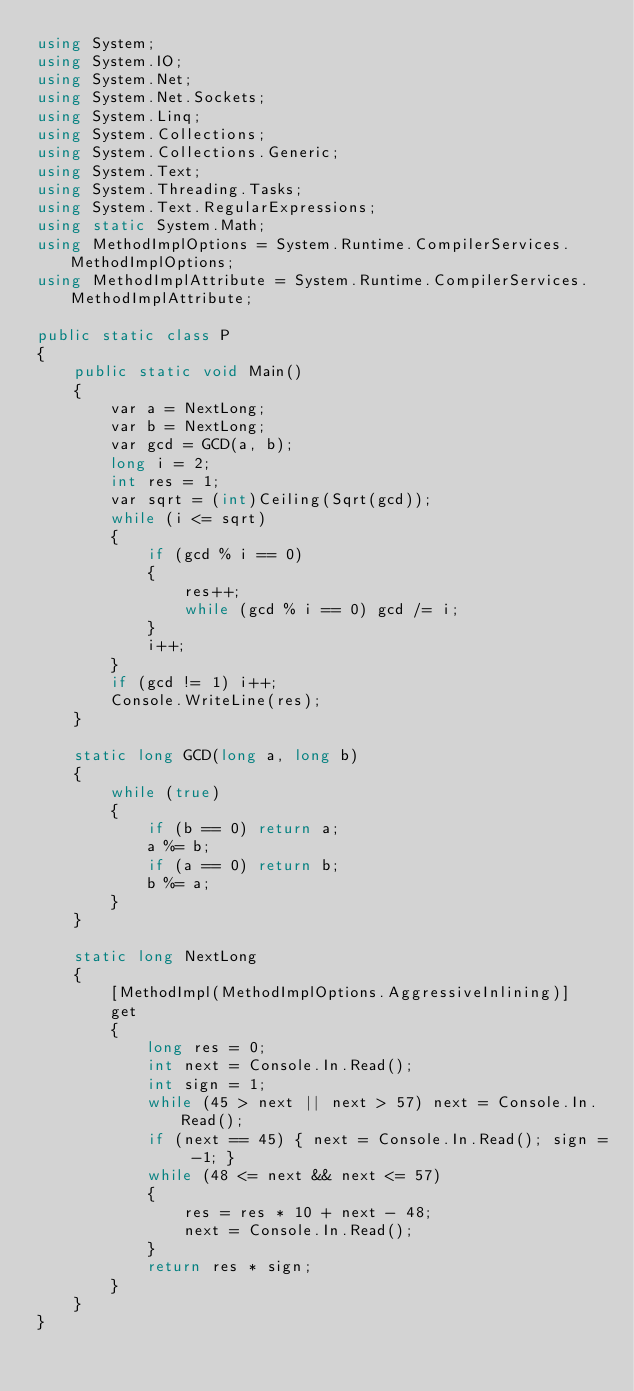Convert code to text. <code><loc_0><loc_0><loc_500><loc_500><_C#_>using System;
using System.IO;
using System.Net;
using System.Net.Sockets;
using System.Linq;
using System.Collections;
using System.Collections.Generic;
using System.Text;
using System.Threading.Tasks;
using System.Text.RegularExpressions;
using static System.Math;
using MethodImplOptions = System.Runtime.CompilerServices.MethodImplOptions;
using MethodImplAttribute = System.Runtime.CompilerServices.MethodImplAttribute;

public static class P
{
    public static void Main()
    {
        var a = NextLong;
        var b = NextLong;
        var gcd = GCD(a, b);
        long i = 2;
        int res = 1;
        var sqrt = (int)Ceiling(Sqrt(gcd));
        while (i <= sqrt)
        {
            if (gcd % i == 0)
            {
                res++;
                while (gcd % i == 0) gcd /= i;
            }
            i++;
        }
        if (gcd != 1) i++;
        Console.WriteLine(res);
    }

    static long GCD(long a, long b)
    {
        while (true)
        {
            if (b == 0) return a;
            a %= b;
            if (a == 0) return b;
            b %= a;
        }
    }

    static long NextLong
    {
        [MethodImpl(MethodImplOptions.AggressiveInlining)]
        get
        {
            long res = 0;
            int next = Console.In.Read();
            int sign = 1;
            while (45 > next || next > 57) next = Console.In.Read();
            if (next == 45) { next = Console.In.Read(); sign = -1; }
            while (48 <= next && next <= 57)
            {
                res = res * 10 + next - 48;
                next = Console.In.Read();
            }
            return res * sign;
        }
    }
}
</code> 